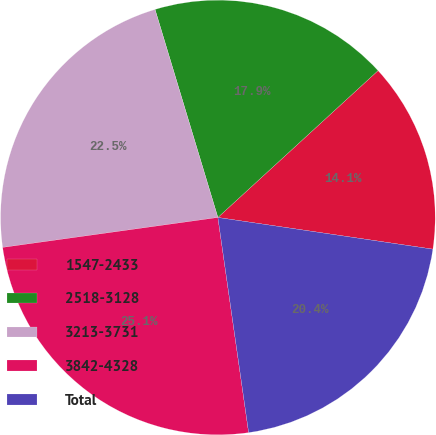<chart> <loc_0><loc_0><loc_500><loc_500><pie_chart><fcel>1547-2433<fcel>2518-3128<fcel>3213-3731<fcel>3842-4328<fcel>Total<nl><fcel>14.14%<fcel>17.86%<fcel>22.53%<fcel>25.06%<fcel>20.41%<nl></chart> 